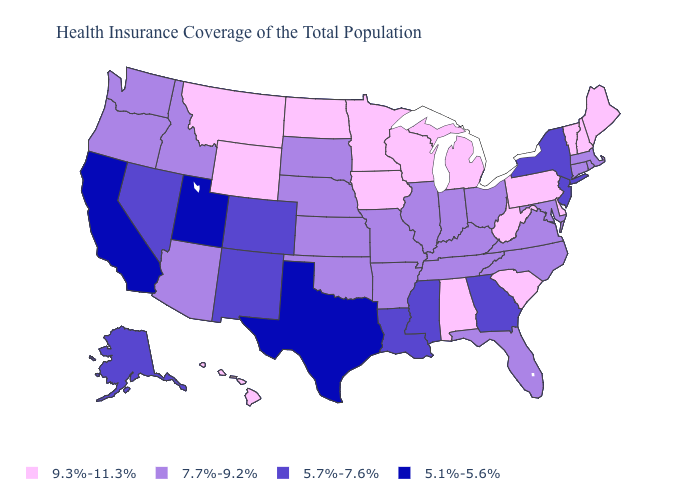What is the value of Kentucky?
Keep it brief. 7.7%-9.2%. What is the value of Oklahoma?
Answer briefly. 7.7%-9.2%. Does Hawaii have the highest value in the West?
Quick response, please. Yes. Which states hav the highest value in the Northeast?
Concise answer only. Maine, New Hampshire, Pennsylvania, Vermont. What is the highest value in the USA?
Concise answer only. 9.3%-11.3%. Does Texas have a lower value than Iowa?
Keep it brief. Yes. What is the value of Alaska?
Short answer required. 5.7%-7.6%. Name the states that have a value in the range 9.3%-11.3%?
Write a very short answer. Alabama, Delaware, Hawaii, Iowa, Maine, Michigan, Minnesota, Montana, New Hampshire, North Dakota, Pennsylvania, South Carolina, Vermont, West Virginia, Wisconsin, Wyoming. Name the states that have a value in the range 5.7%-7.6%?
Write a very short answer. Alaska, Colorado, Georgia, Louisiana, Mississippi, Nevada, New Jersey, New Mexico, New York. Among the states that border Oregon , does California have the highest value?
Quick response, please. No. What is the highest value in states that border Massachusetts?
Quick response, please. 9.3%-11.3%. Name the states that have a value in the range 5.1%-5.6%?
Be succinct. California, Texas, Utah. What is the highest value in the USA?
Keep it brief. 9.3%-11.3%. Does the first symbol in the legend represent the smallest category?
Quick response, please. No. Is the legend a continuous bar?
Keep it brief. No. 